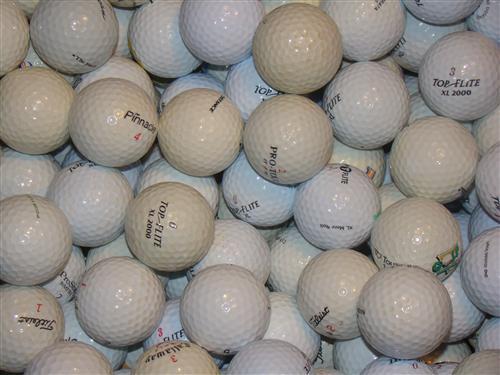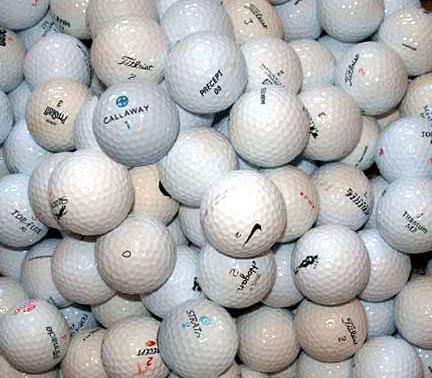The first image is the image on the left, the second image is the image on the right. Assess this claim about the two images: "The golfballs in the image on the right are not in shadow.". Correct or not? Answer yes or no. Yes. 